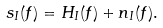Convert formula to latex. <formula><loc_0><loc_0><loc_500><loc_500>s _ { I } ( f ) = H _ { I } ( f ) + n _ { I } ( f ) .</formula> 